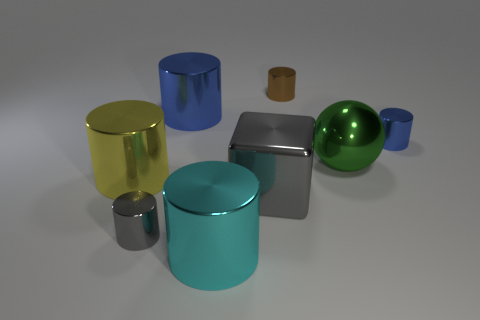Subtract 1 cylinders. How many cylinders are left? 5 Subtract all gray cylinders. How many cylinders are left? 5 Subtract all large yellow metallic cylinders. How many cylinders are left? 5 Subtract all purple cylinders. Subtract all gray spheres. How many cylinders are left? 6 Add 1 tiny blue things. How many objects exist? 9 Subtract all cylinders. How many objects are left? 2 Add 8 blue metal cylinders. How many blue metal cylinders are left? 10 Add 5 red blocks. How many red blocks exist? 5 Subtract 0 green cylinders. How many objects are left? 8 Subtract all yellow spheres. Subtract all blue objects. How many objects are left? 6 